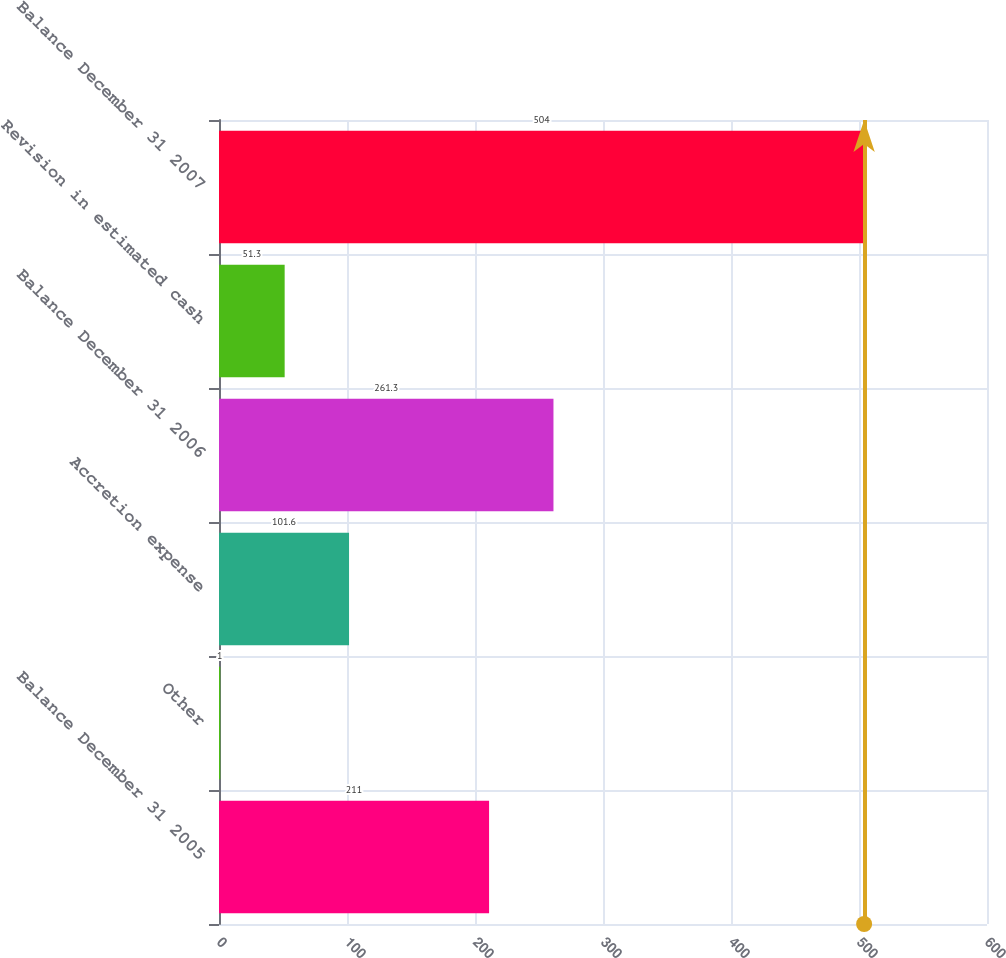Convert chart to OTSL. <chart><loc_0><loc_0><loc_500><loc_500><bar_chart><fcel>Balance December 31 2005<fcel>Other<fcel>Accretion expense<fcel>Balance December 31 2006<fcel>Revision in estimated cash<fcel>Balance December 31 2007<nl><fcel>211<fcel>1<fcel>101.6<fcel>261.3<fcel>51.3<fcel>504<nl></chart> 